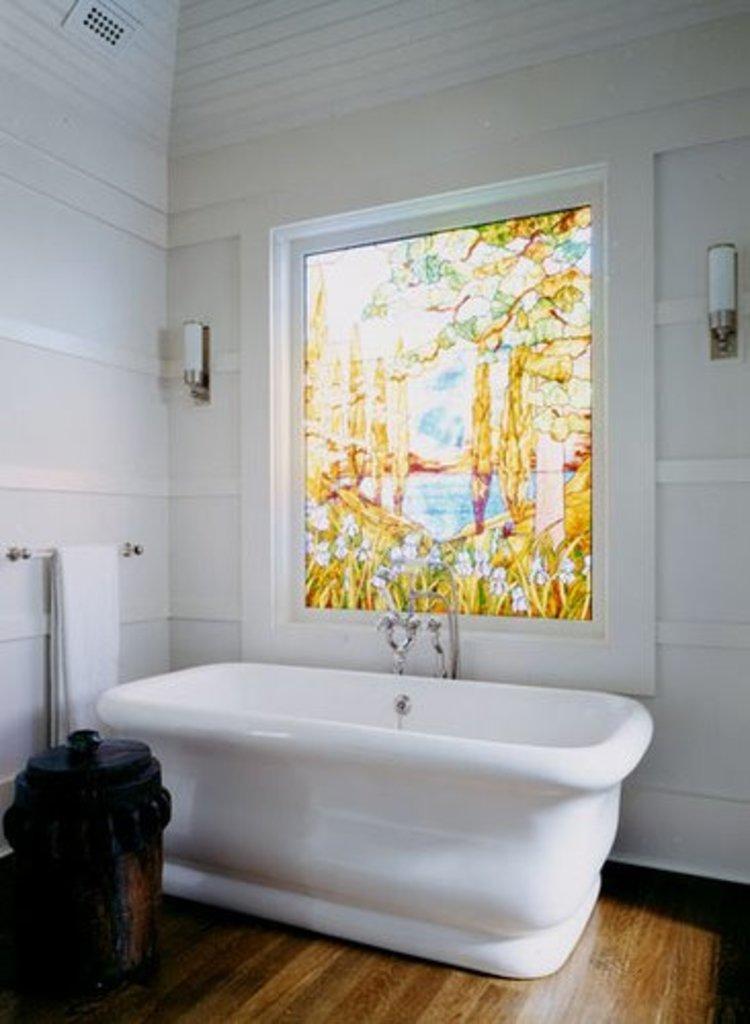Could you give a brief overview of what you see in this image? There is a dustbin, bath towel and a bathtub present at the bottom of this image. We can see a wall in the background. There is a window in the middle of this image. We can see an object present on the right side of this image and is on the left side of this image as well. 